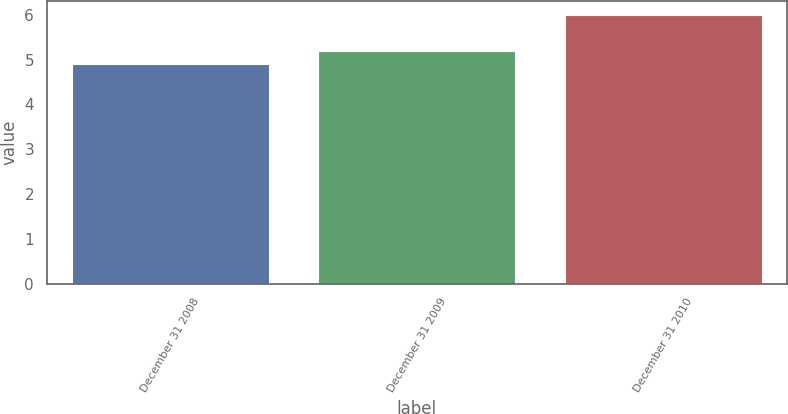Convert chart. <chart><loc_0><loc_0><loc_500><loc_500><bar_chart><fcel>December 31 2008<fcel>December 31 2009<fcel>December 31 2010<nl><fcel>4.9<fcel>5.2<fcel>6<nl></chart> 